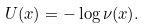<formula> <loc_0><loc_0><loc_500><loc_500>U ( x ) = - \log \nu ( x ) .</formula> 